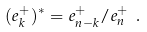Convert formula to latex. <formula><loc_0><loc_0><loc_500><loc_500>( e _ { k } ^ { + } ) ^ { \ast } = e _ { n - k } ^ { + } / e _ { n } ^ { + } \ .</formula> 